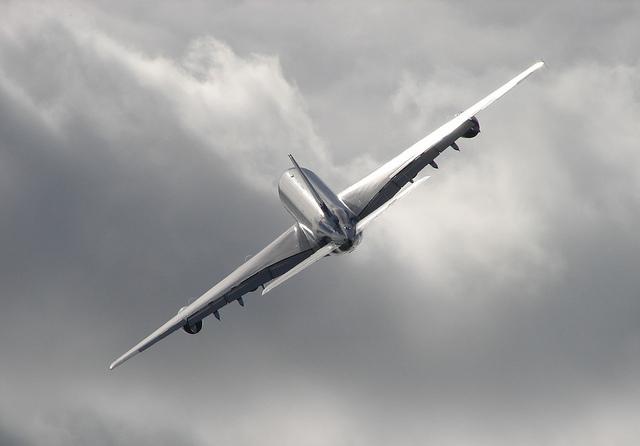What is flying in the sky?
Be succinct. Airplane. Which way is the plane banking?
Write a very short answer. Left. How is the sky?
Keep it brief. Cloudy. 